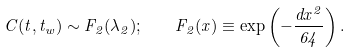Convert formula to latex. <formula><loc_0><loc_0><loc_500><loc_500>C ( t , t _ { w } ) \sim F _ { 2 } ( \lambda _ { 2 } ) ; \quad F _ { 2 } ( x ) \equiv \exp \left ( - \frac { d x ^ { 2 } } { 6 4 } \right ) .</formula> 